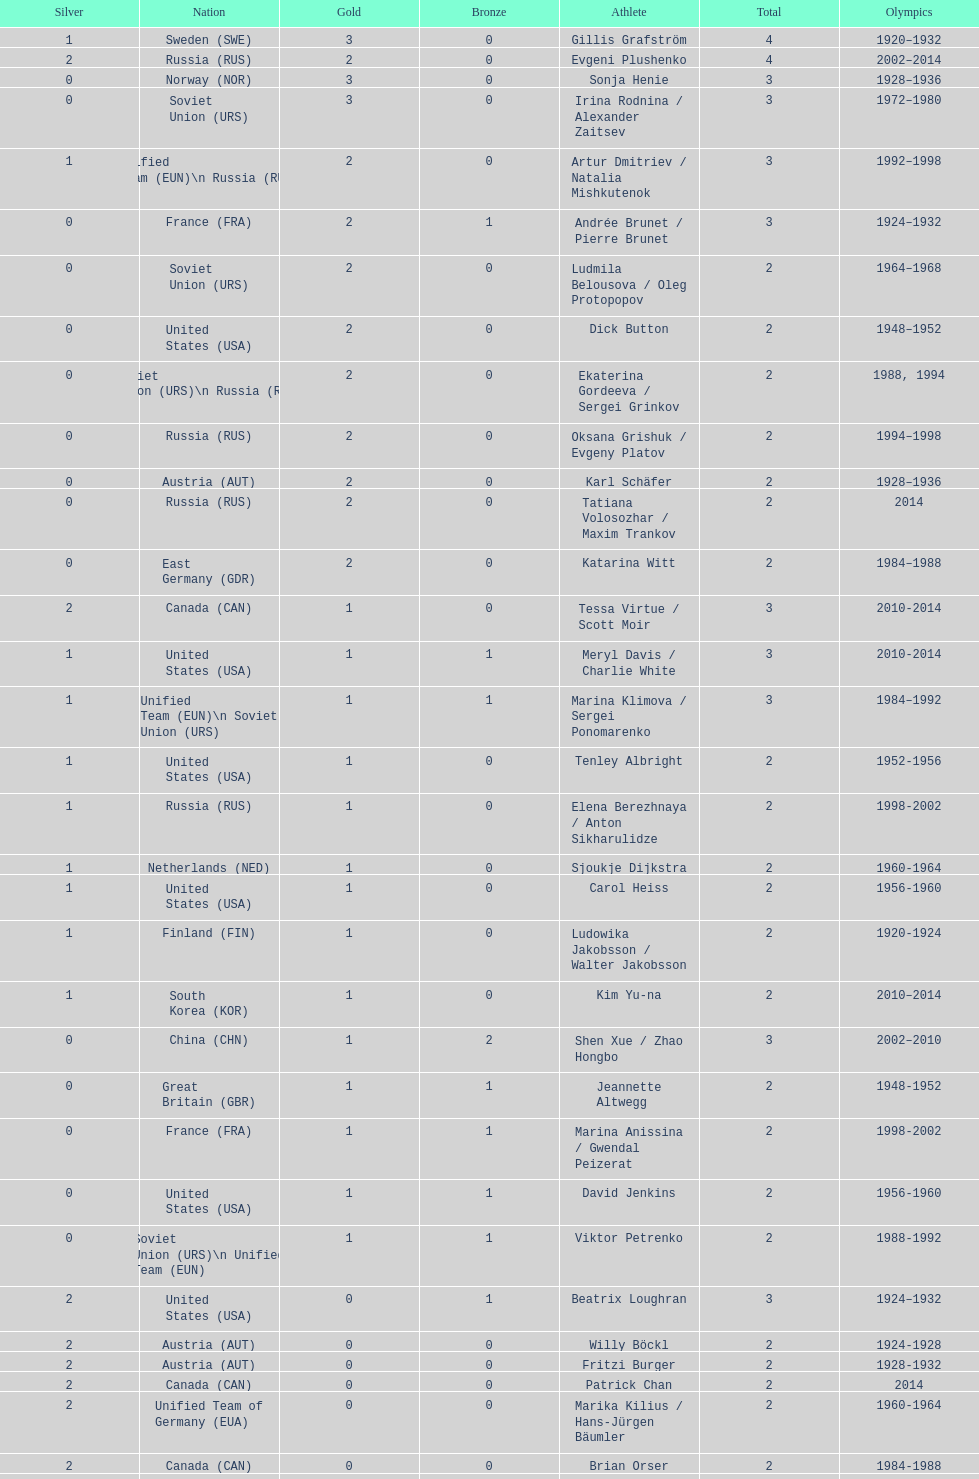How many medals have sweden and norway won combined? 7. 